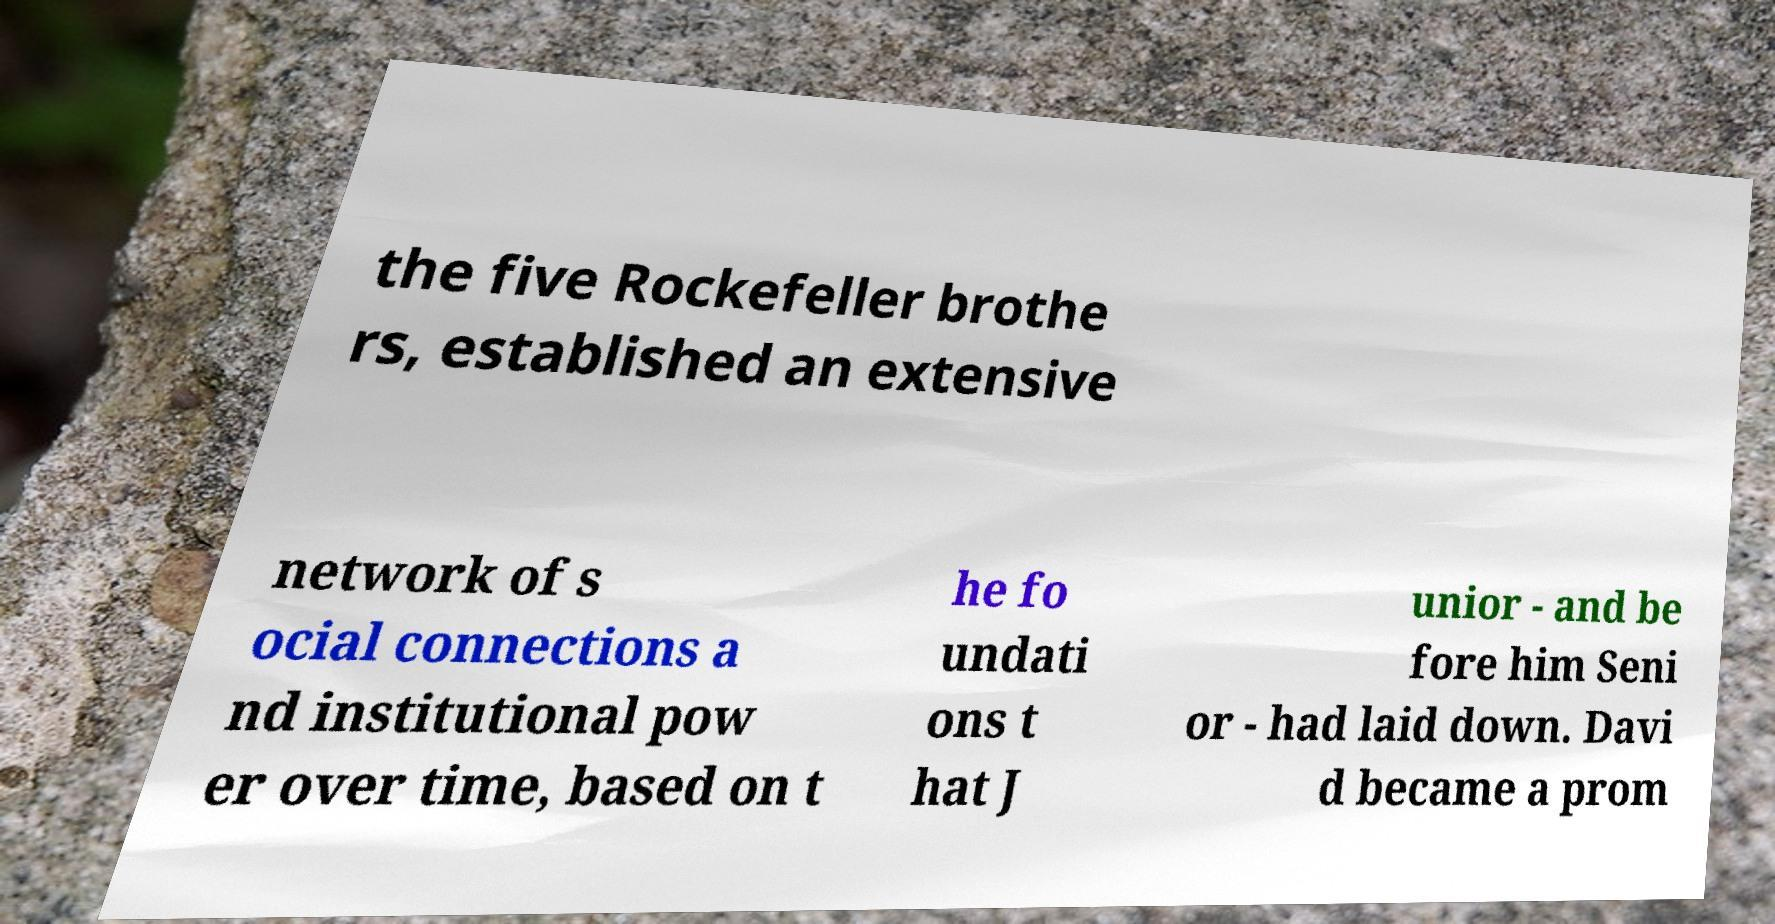What messages or text are displayed in this image? I need them in a readable, typed format. the five Rockefeller brothe rs, established an extensive network of s ocial connections a nd institutional pow er over time, based on t he fo undati ons t hat J unior - and be fore him Seni or - had laid down. Davi d became a prom 